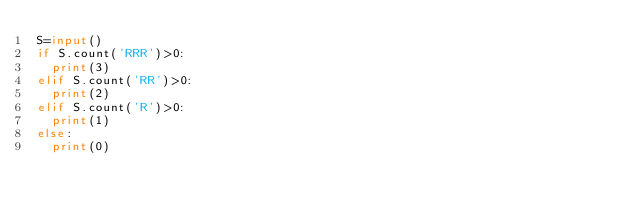Convert code to text. <code><loc_0><loc_0><loc_500><loc_500><_Python_>S=input()
if S.count('RRR')>0:
  print(3)
elif S.count('RR')>0:
  print(2)
elif S.count('R')>0:
  print(1)
else:
  print(0)</code> 